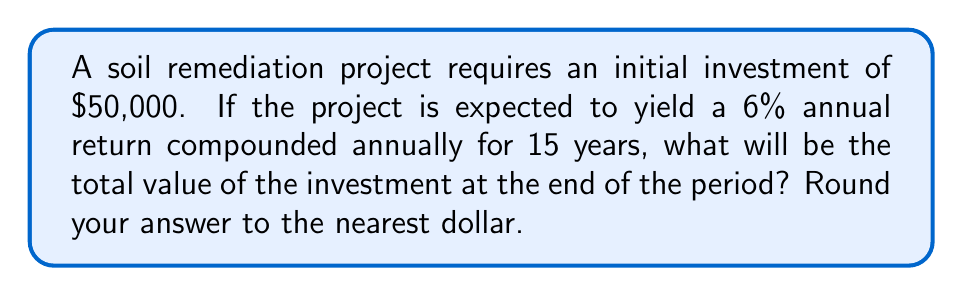What is the answer to this math problem? To solve this problem, we'll use the compound interest formula:

$$A = P(1 + r)^t$$

Where:
$A$ = final amount
$P$ = principal (initial investment)
$r$ = annual interest rate (as a decimal)
$t$ = time in years

Given:
$P = \$50,000$
$r = 0.06$ (6% expressed as a decimal)
$t = 15$ years

Let's plug these values into the formula:

$$A = 50,000(1 + 0.06)^{15}$$

Now, let's calculate step by step:

1) First, calculate $(1 + 0.06)^{15}$:
   $$(1.06)^{15} \approx 2.3965816$$

2) Multiply this by the principal:
   $$50,000 \times 2.3965816 = 119,829.08$$

3) Round to the nearest dollar:
   $$119,829$$

Therefore, the total value of the investment after 15 years will be $119,829.
Answer: $119,829 